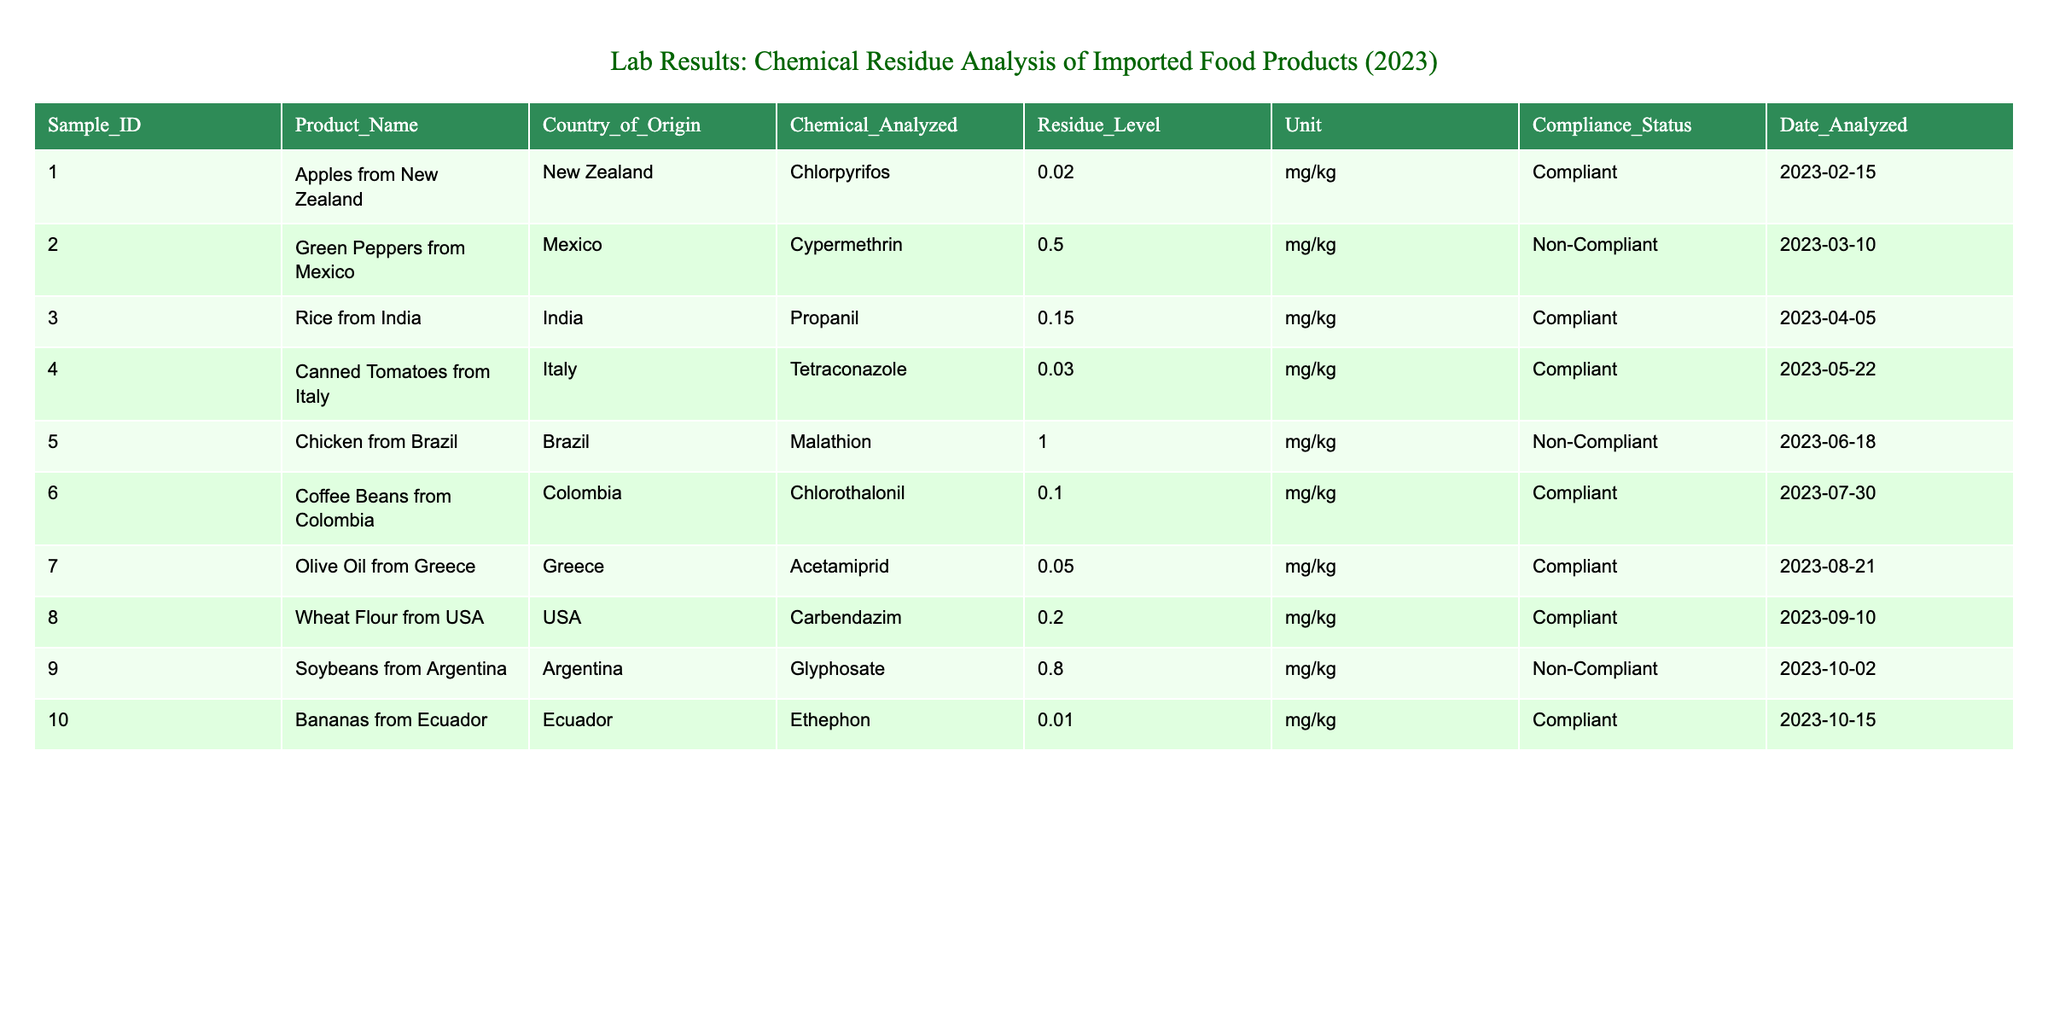What is the residue level of Cypermethrin in Green Peppers from Mexico? The table shows that the residue level of Cypermethrin in Green Peppers from Mexico is listed as 0.50 mg/kg.
Answer: 0.50 mg/kg How many compliant products are listed in the table? By reviewing the compliance status for each product, there are 7 products marked as compliant: Apples from New Zealand, Rice from India, Canned Tomatoes from Italy, Coffee Beans from Colombia, Olive Oil from Greece, Wheat Flour from USA, and Bananas from Ecuador.
Answer: 7 What is the maximum residue level detected in this table? The table lists residue levels of various chemicals. The maximum value is 1.00 mg/kg for Malathion in Chicken from Brazil.
Answer: 1.00 mg/kg Are there any products compliant with residue levels of Ethephon? According to the table, Ethephon is detected in Bananas from Ecuador with a residue level of 0.01 mg/kg, and it is marked as compliant.
Answer: Yes What is the average residue level of non-compliant products? The non-compliant products are Green Peppers (0.50 mg/kg), Chicken (1.00 mg/kg), and Soybeans (0.80 mg/kg). Their total residue level is 0.50 + 1.00 + 0.80 = 2.30 mg/kg. There are 3 non-compliant products, so the average is 2.30 / 3 = 0.7667 mg/kg.
Answer: 0.77 mg/kg Which country has the highest level of chemical residue detected? Based on the residue level data, Chicken from Brazil has the highest level of chemical residue at 1.00 mg/kg noted for Malathion.
Answer: Brazil Is there a compliant product from Columbia? Examining the table, Coffee Beans from Colombia is compliant with a residue level of 0.10 mg/kg for Chlorothalonil.
Answer: Yes How many products are imported from countries that have non-compliant items? The countries with non-compliant items are Mexico (Green Peppers), Brazil (Chicken), and Argentina (Soybeans). The table lists 3 products from these countries, confirming that the non-compliant items came from separate imports.
Answer: 3 